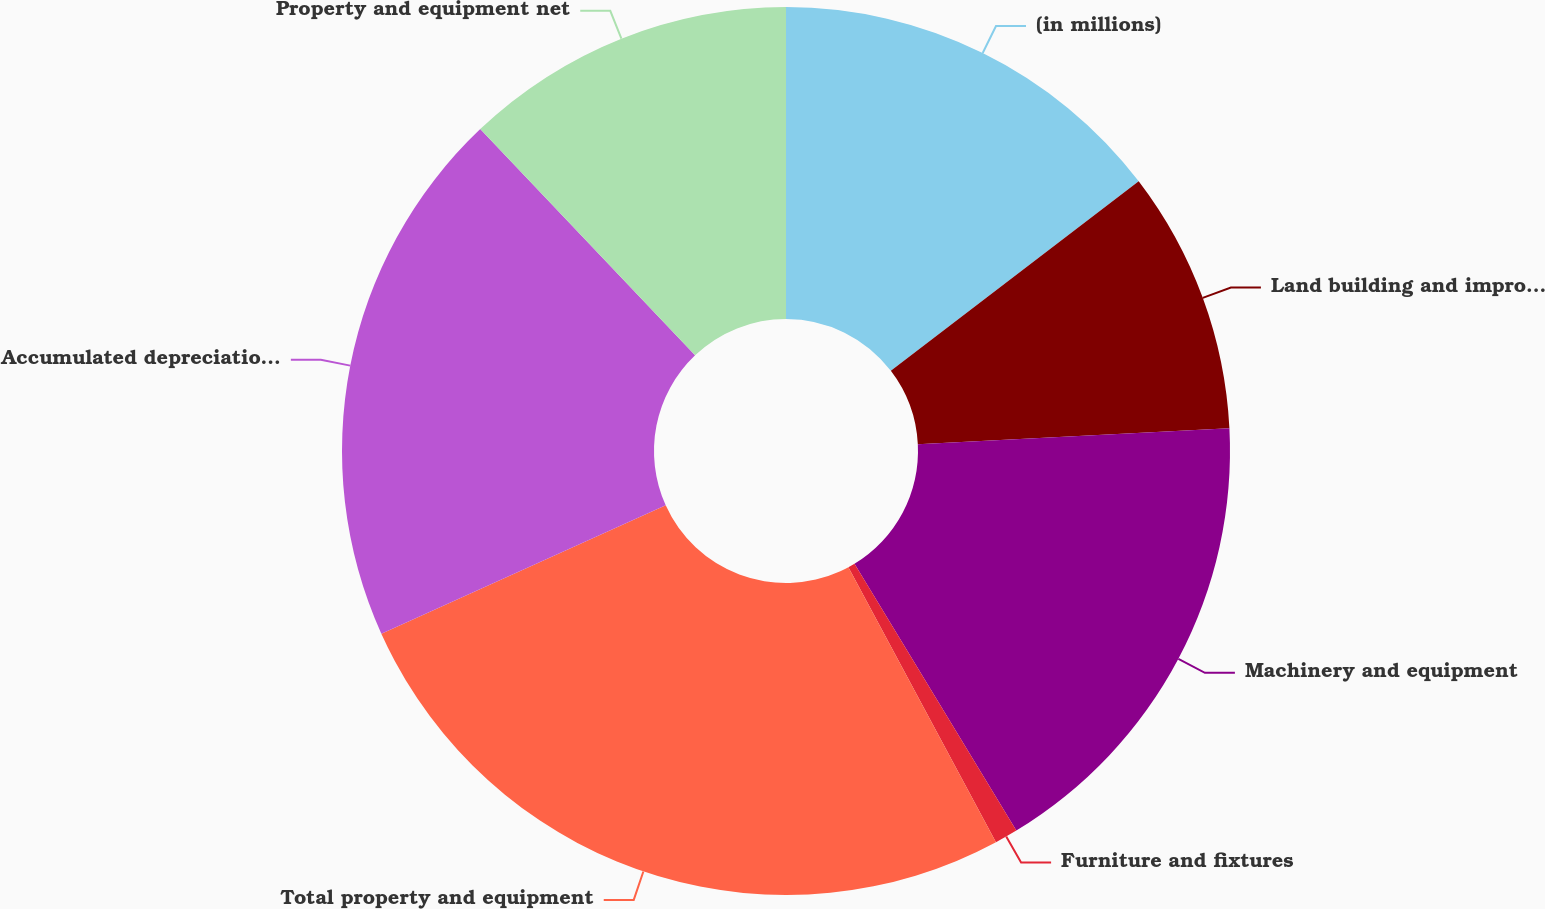Convert chart to OTSL. <chart><loc_0><loc_0><loc_500><loc_500><pie_chart><fcel>(in millions)<fcel>Land building and improvements<fcel>Machinery and equipment<fcel>Furniture and fixtures<fcel>Total property and equipment<fcel>Accumulated depreciation and<fcel>Property and equipment net<nl><fcel>14.61%<fcel>9.57%<fcel>17.14%<fcel>0.84%<fcel>26.09%<fcel>19.66%<fcel>12.09%<nl></chart> 